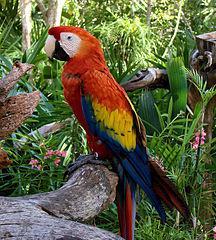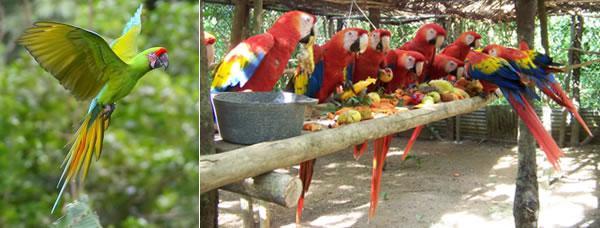The first image is the image on the left, the second image is the image on the right. Given the left and right images, does the statement "All of the birds in the images are sitting in the branches of trees." hold true? Answer yes or no. No. The first image is the image on the left, the second image is the image on the right. Given the left and right images, does the statement "There are no more than three birds in the pair of images." hold true? Answer yes or no. No. 